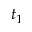<formula> <loc_0><loc_0><loc_500><loc_500>t _ { 1 }</formula> 